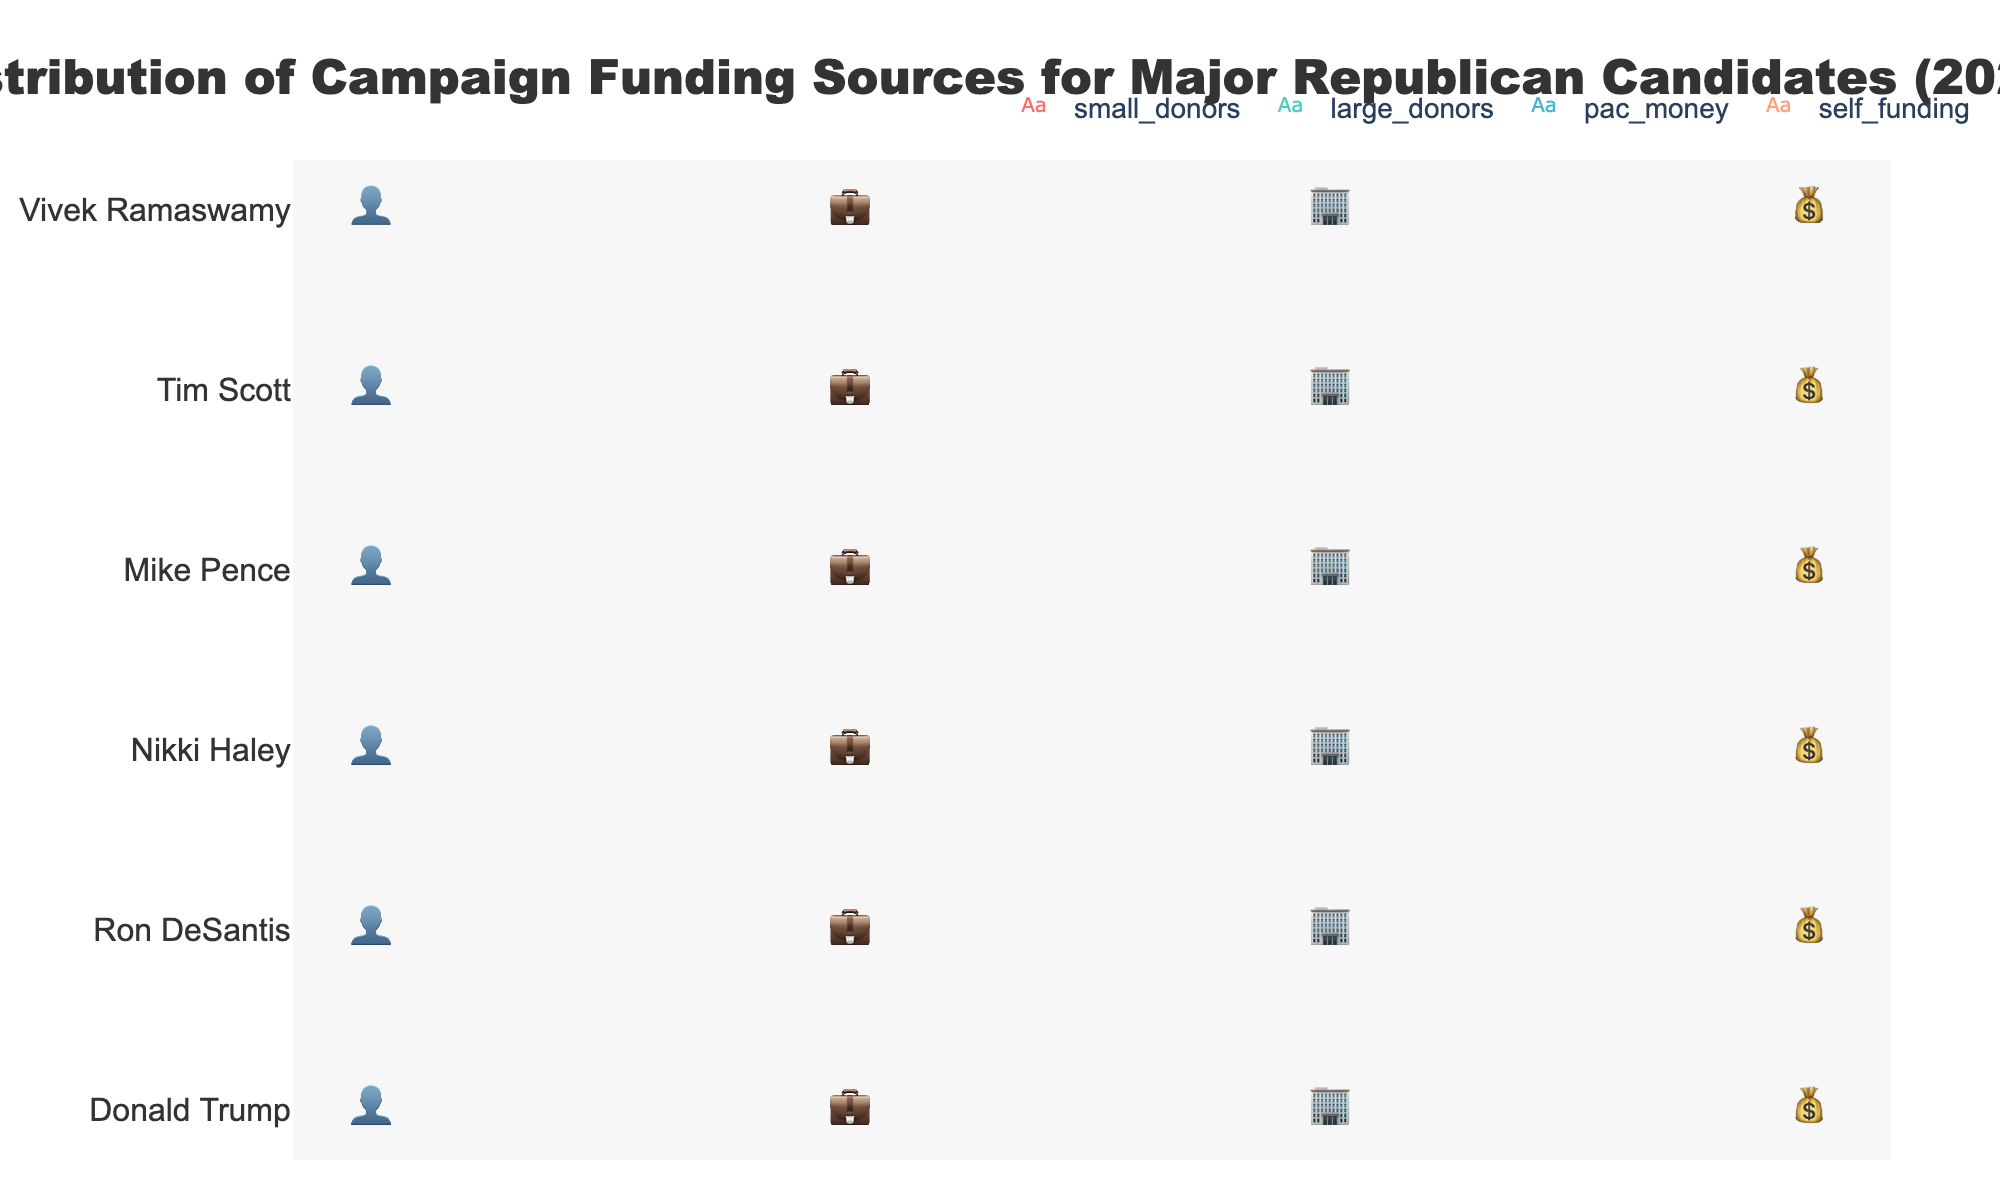What is the title of the figure? The title is located at the top of the figure, centered and in bold text. The title reads "Distribution of Campaign Funding Sources for Major Republican Candidates (2024)."
Answer: Distribution of Campaign Funding Sources for Major Republican Candidates (2024) Which candidate has the highest percentage of self-funding? Identify each candidate's self-funding icons and compare them. Vivek Ramaswamy has the most with 60 icons.
Answer: Vivek Ramaswamy How does Nikki Haley's funding from large donors compare to Mike Pence's? Count the icons for large donors in Nikki Haley's row and compare it to those in Mike Pence's row. Nikki Haley has 9 icons, while Mike Pence has 10 icons.
Answer: Mike Pence has more Which category has the most diverse sources of funding among candidates? Observe each funding category (small donors, large donors, PAC money, self-funding) for the candidates and see which one has the most variation in icon counts. The large donors' category shows a range from 2 to 11 icons among the candidates.
Answer: Large donors Which candidate relies more on PAC money relative to small donors? Compare the icons for PAC money and small donors for each candidate. Mike Pence has 5 icons for PAC money and 4 for small donors, showing more reliance on PAC money relative to small donors.
Answer: Mike Pence What is the average percentage of PAC money for Ron DeSantis and Nikki Haley? Calculate the sum of the percentages for Ron DeSantis (20) and Nikki Haley (25), and then divide by 2. (20+25)/2 = 22.5.
Answer: 22.5% How many total icons represent the campaign funds for Donald Trump? Sum the icons for small donors, large donors, PAC money, and self-funding for Donald Trump: 10 (small) + 6 (large) + 3 (PAC) + 1 (self) = 20.
Answer: 20 Which candidate has the least variation between the different funding sources? Review each candidate's icon counts across the different sources and identify the smallest range. All candidates except Vivek Ramaswamy have small variations due to similar self-funding and slightly different values in other categories.
Answer: All candidates except Vivek Ramaswamy have low variation Do any candidates have a percentage of small donors equal to the percentage of PAC money? Compare each candidate's small donor icons to their PAC money icons. None of the candidates have matching icons for these categories.
Answer: No 